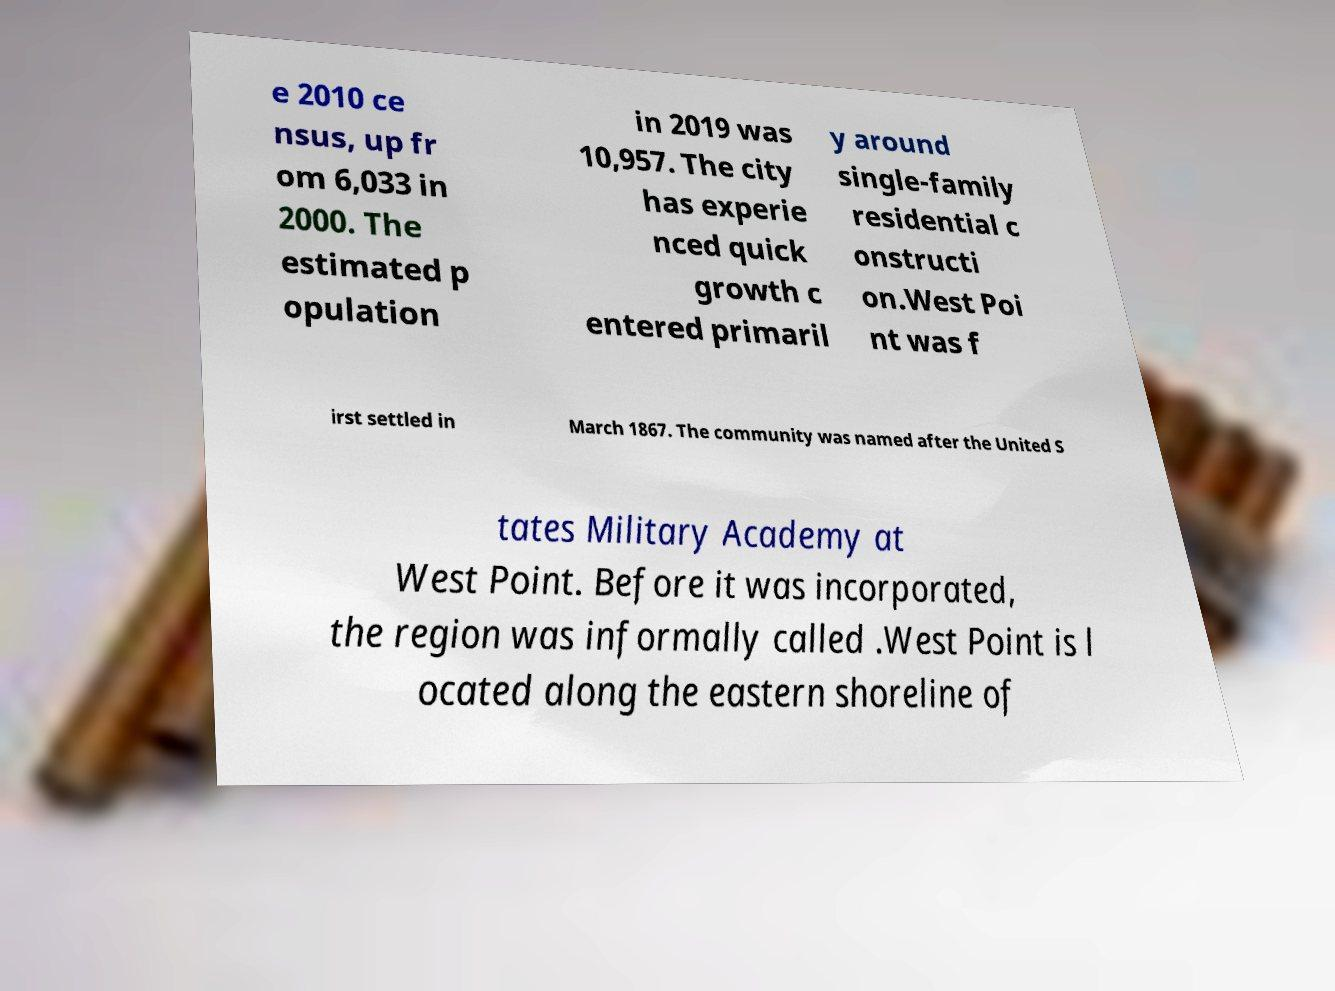Please read and relay the text visible in this image. What does it say? e 2010 ce nsus, up fr om 6,033 in 2000. The estimated p opulation in 2019 was 10,957. The city has experie nced quick growth c entered primaril y around single-family residential c onstructi on.West Poi nt was f irst settled in March 1867. The community was named after the United S tates Military Academy at West Point. Before it was incorporated, the region was informally called .West Point is l ocated along the eastern shoreline of 